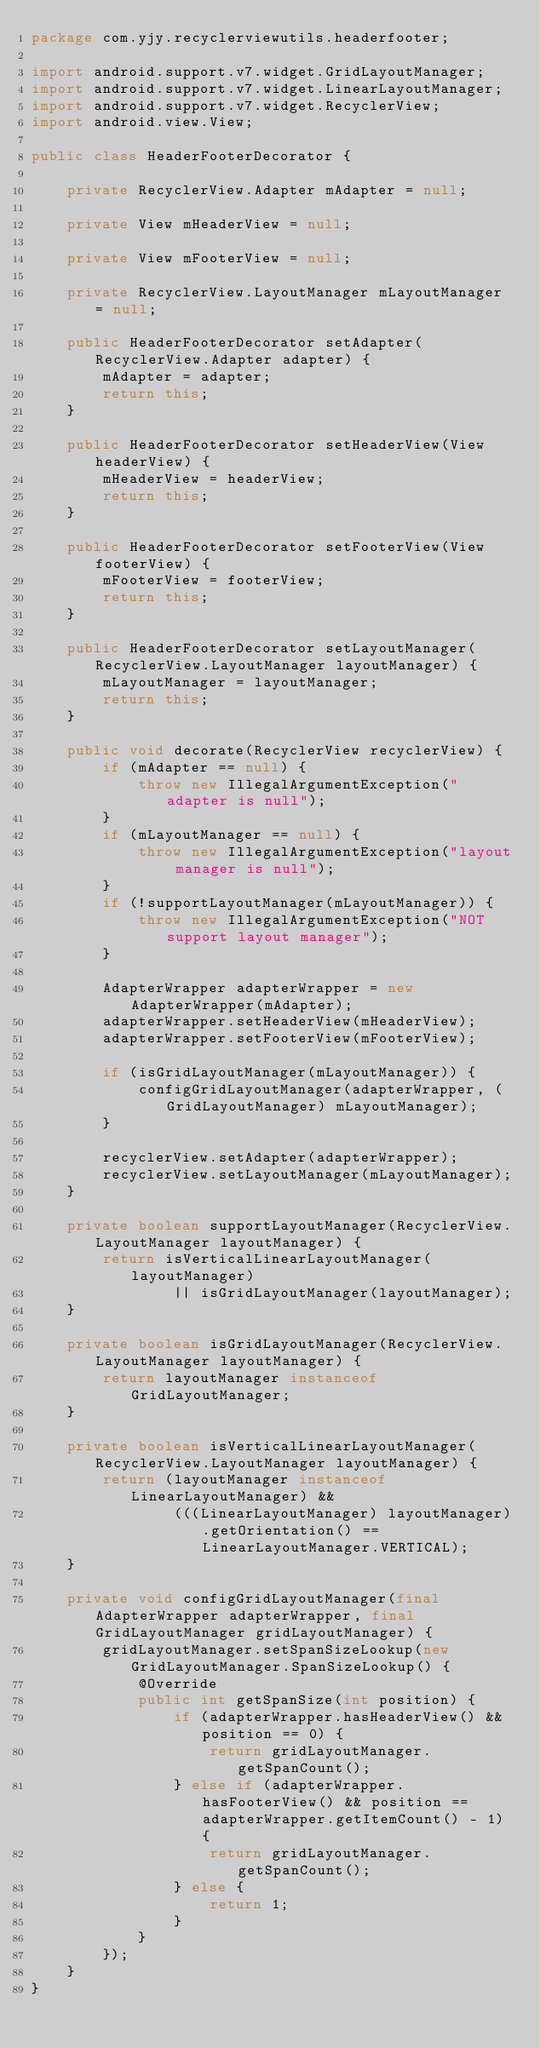Convert code to text. <code><loc_0><loc_0><loc_500><loc_500><_Java_>package com.yjy.recyclerviewutils.headerfooter;

import android.support.v7.widget.GridLayoutManager;
import android.support.v7.widget.LinearLayoutManager;
import android.support.v7.widget.RecyclerView;
import android.view.View;

public class HeaderFooterDecorator {

    private RecyclerView.Adapter mAdapter = null;

    private View mHeaderView = null;

    private View mFooterView = null;

    private RecyclerView.LayoutManager mLayoutManager = null;

    public HeaderFooterDecorator setAdapter(RecyclerView.Adapter adapter) {
        mAdapter = adapter;
        return this;
    }

    public HeaderFooterDecorator setHeaderView(View headerView) {
        mHeaderView = headerView;
        return this;
    }

    public HeaderFooterDecorator setFooterView(View footerView) {
        mFooterView = footerView;
        return this;
    }

    public HeaderFooterDecorator setLayoutManager(RecyclerView.LayoutManager layoutManager) {
        mLayoutManager = layoutManager;
        return this;
    }

    public void decorate(RecyclerView recyclerView) {
        if (mAdapter == null) {
            throw new IllegalArgumentException("adapter is null");
        }
        if (mLayoutManager == null) {
            throw new IllegalArgumentException("layout manager is null");
        }
        if (!supportLayoutManager(mLayoutManager)) {
            throw new IllegalArgumentException("NOT support layout manager");
        }

        AdapterWrapper adapterWrapper = new AdapterWrapper(mAdapter);
        adapterWrapper.setHeaderView(mHeaderView);
        adapterWrapper.setFooterView(mFooterView);

        if (isGridLayoutManager(mLayoutManager)) {
            configGridLayoutManager(adapterWrapper, (GridLayoutManager) mLayoutManager);
        }

        recyclerView.setAdapter(adapterWrapper);
        recyclerView.setLayoutManager(mLayoutManager);
    }

    private boolean supportLayoutManager(RecyclerView.LayoutManager layoutManager) {
        return isVerticalLinearLayoutManager(layoutManager)
                || isGridLayoutManager(layoutManager);
    }

    private boolean isGridLayoutManager(RecyclerView.LayoutManager layoutManager) {
        return layoutManager instanceof GridLayoutManager;
    }

    private boolean isVerticalLinearLayoutManager(RecyclerView.LayoutManager layoutManager) {
        return (layoutManager instanceof LinearLayoutManager) &&
                (((LinearLayoutManager) layoutManager).getOrientation() == LinearLayoutManager.VERTICAL);
    }

    private void configGridLayoutManager(final AdapterWrapper adapterWrapper, final GridLayoutManager gridLayoutManager) {
        gridLayoutManager.setSpanSizeLookup(new GridLayoutManager.SpanSizeLookup() {
            @Override
            public int getSpanSize(int position) {
                if (adapterWrapper.hasHeaderView() && position == 0) {
                    return gridLayoutManager.getSpanCount();
                } else if (adapterWrapper.hasFooterView() && position == adapterWrapper.getItemCount() - 1) {
                    return gridLayoutManager.getSpanCount();
                } else {
                    return 1;
                }
            }
        });
    }
}
</code> 